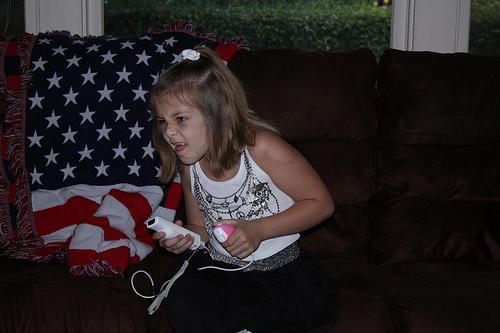How many pink controllers are in this image?
Give a very brief answer. 0. 